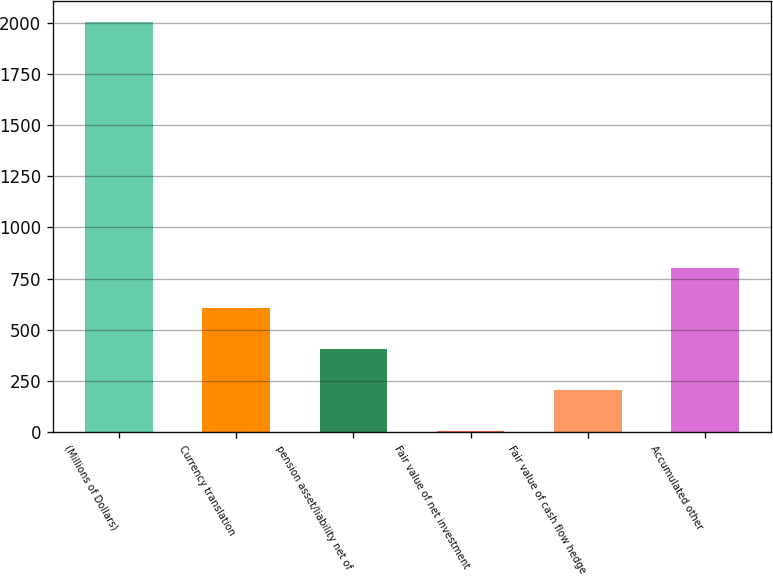<chart> <loc_0><loc_0><loc_500><loc_500><bar_chart><fcel>(Millions of Dollars)<fcel>Currency translation<fcel>pension asset/liability net of<fcel>Fair value of net investment<fcel>Fair value of cash flow hedge<fcel>Accumulated other<nl><fcel>2004<fcel>603.72<fcel>403.68<fcel>3.6<fcel>203.64<fcel>803.76<nl></chart> 